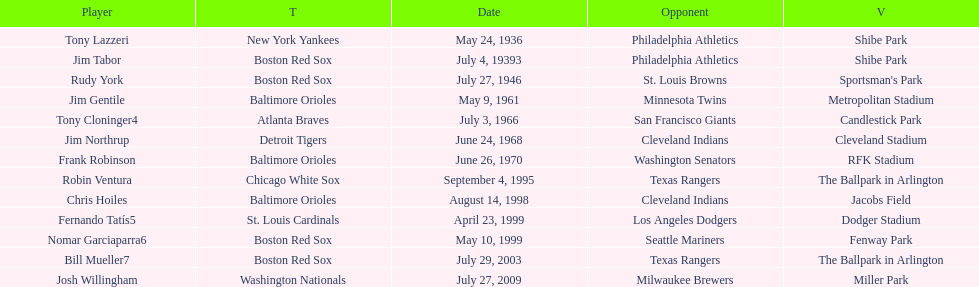What was the name of the player who accomplished this in 1999 but played for the boston red sox? Nomar Garciaparra. 